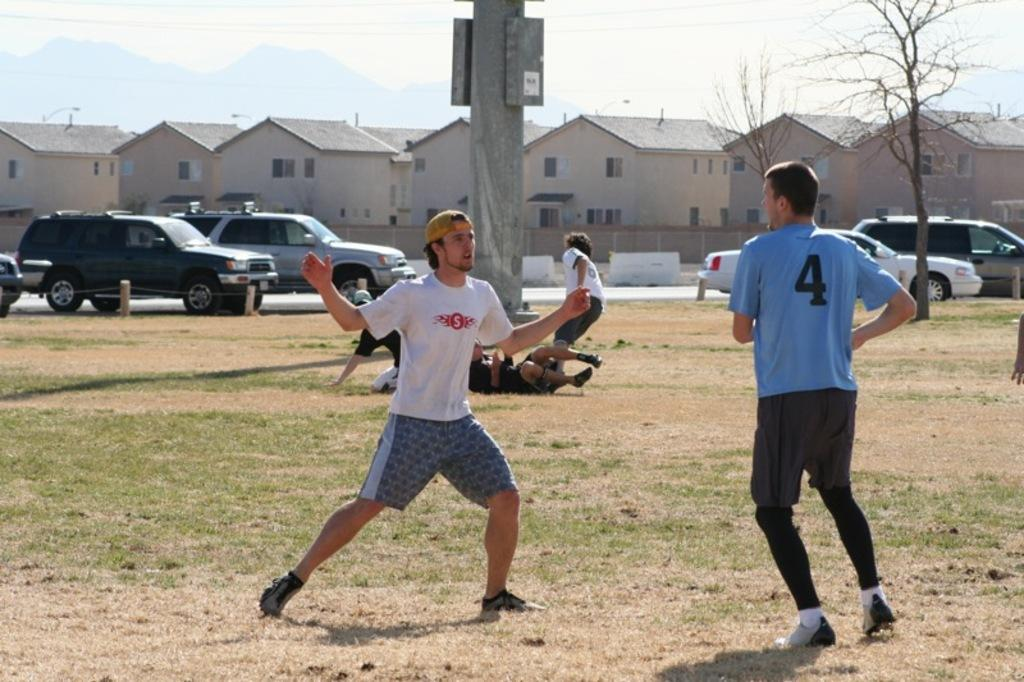How many people can be seen in the image? There are people in the image, but the exact number is not specified. What type of terrain is visible in the image? There is grass and sand visible in the image. What type of structures are present in the image? There are houses, a fencing wall, and a pillar in the image. What type of infrastructure is present in the image? There are wires and vehicles on the road in the image. What can be seen in the sky in the image? The sky is visible in the image, but the specific weather or time of day is not mentioned. What color is the mine in the image? There is no mine present in the image. What type of flag is being flown on the flagpole in the image? There is no flagpole or flag present in the image. 